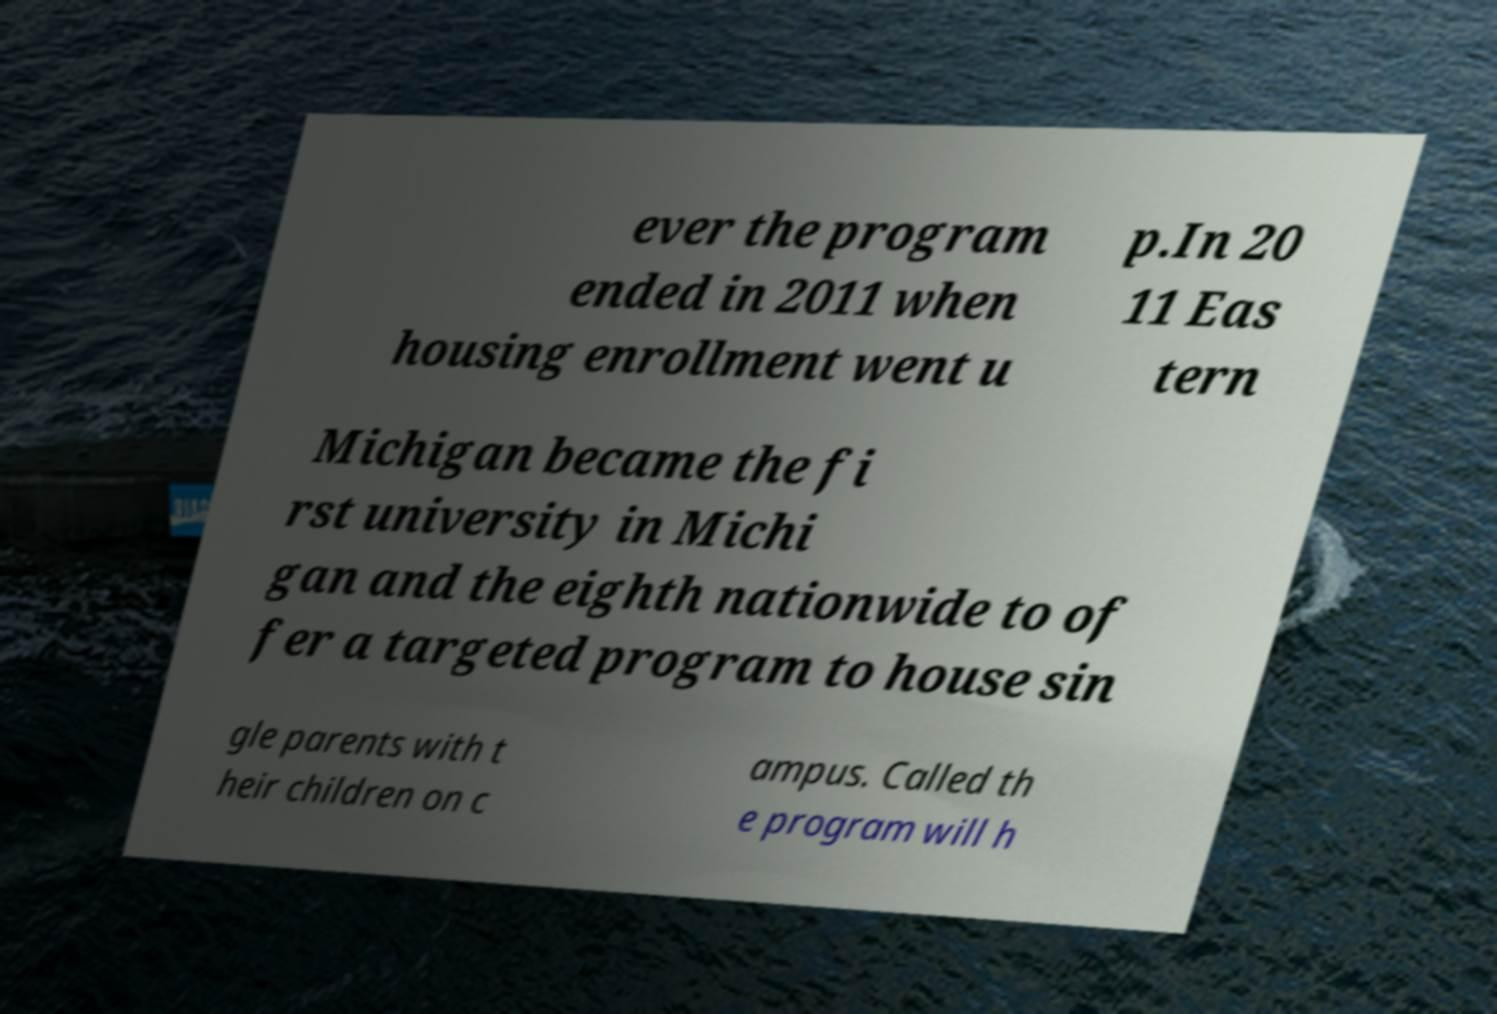Please identify and transcribe the text found in this image. ever the program ended in 2011 when housing enrollment went u p.In 20 11 Eas tern Michigan became the fi rst university in Michi gan and the eighth nationwide to of fer a targeted program to house sin gle parents with t heir children on c ampus. Called th e program will h 